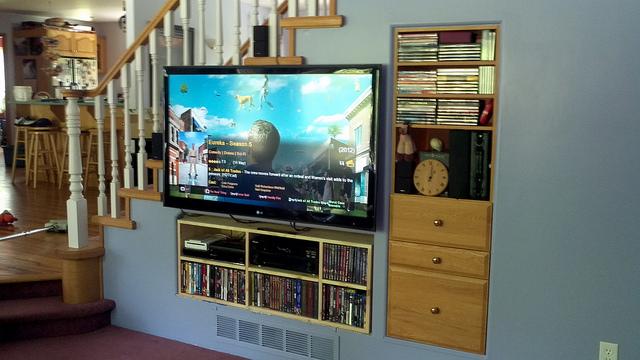What room is this?
Be succinct. Living room. What's lying in the floor?
Keep it brief. Broom. What time is shown on the TV?
Keep it brief. 1:00. Is the tv on?
Answer briefly. Yes. 